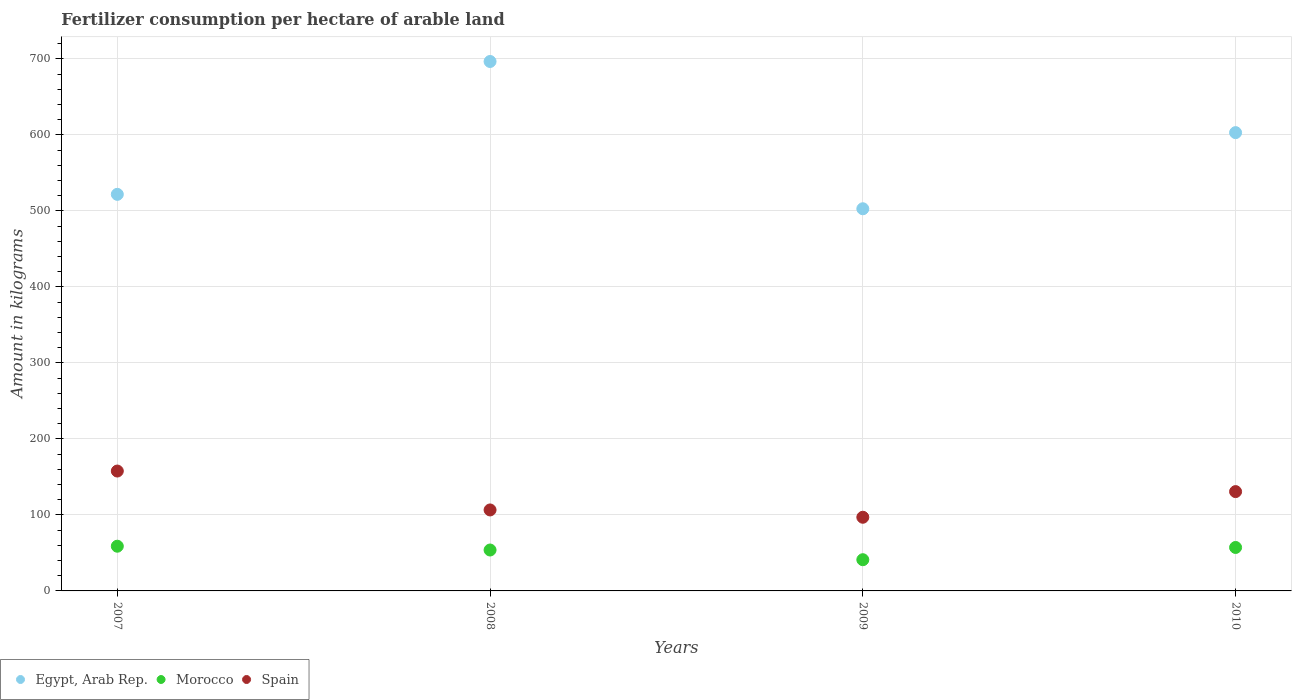Is the number of dotlines equal to the number of legend labels?
Offer a terse response. Yes. What is the amount of fertilizer consumption in Spain in 2008?
Give a very brief answer. 106.54. Across all years, what is the maximum amount of fertilizer consumption in Morocco?
Offer a very short reply. 58.83. Across all years, what is the minimum amount of fertilizer consumption in Morocco?
Your response must be concise. 41.07. What is the total amount of fertilizer consumption in Egypt, Arab Rep. in the graph?
Give a very brief answer. 2324.19. What is the difference between the amount of fertilizer consumption in Spain in 2007 and that in 2008?
Offer a terse response. 51.18. What is the difference between the amount of fertilizer consumption in Egypt, Arab Rep. in 2009 and the amount of fertilizer consumption in Morocco in 2008?
Offer a terse response. 449. What is the average amount of fertilizer consumption in Morocco per year?
Give a very brief answer. 52.72. In the year 2008, what is the difference between the amount of fertilizer consumption in Morocco and amount of fertilizer consumption in Egypt, Arab Rep.?
Your answer should be very brief. -642.77. What is the ratio of the amount of fertilizer consumption in Egypt, Arab Rep. in 2007 to that in 2008?
Offer a terse response. 0.75. Is the amount of fertilizer consumption in Morocco in 2008 less than that in 2010?
Offer a very short reply. Yes. What is the difference between the highest and the second highest amount of fertilizer consumption in Egypt, Arab Rep.?
Provide a succinct answer. 93.61. What is the difference between the highest and the lowest amount of fertilizer consumption in Spain?
Ensure brevity in your answer.  60.8. In how many years, is the amount of fertilizer consumption in Spain greater than the average amount of fertilizer consumption in Spain taken over all years?
Ensure brevity in your answer.  2. Is the amount of fertilizer consumption in Egypt, Arab Rep. strictly greater than the amount of fertilizer consumption in Morocco over the years?
Your response must be concise. Yes. Are the values on the major ticks of Y-axis written in scientific E-notation?
Your answer should be compact. No. Does the graph contain any zero values?
Make the answer very short. No. How many legend labels are there?
Give a very brief answer. 3. How are the legend labels stacked?
Provide a short and direct response. Horizontal. What is the title of the graph?
Your response must be concise. Fertilizer consumption per hectare of arable land. Does "French Polynesia" appear as one of the legend labels in the graph?
Give a very brief answer. No. What is the label or title of the X-axis?
Keep it short and to the point. Years. What is the label or title of the Y-axis?
Your answer should be compact. Amount in kilograms. What is the Amount in kilograms of Egypt, Arab Rep. in 2007?
Make the answer very short. 521.79. What is the Amount in kilograms of Morocco in 2007?
Keep it short and to the point. 58.83. What is the Amount in kilograms in Spain in 2007?
Provide a succinct answer. 157.72. What is the Amount in kilograms in Egypt, Arab Rep. in 2008?
Ensure brevity in your answer.  696.59. What is the Amount in kilograms of Morocco in 2008?
Provide a succinct answer. 53.83. What is the Amount in kilograms in Spain in 2008?
Provide a short and direct response. 106.54. What is the Amount in kilograms of Egypt, Arab Rep. in 2009?
Provide a succinct answer. 502.83. What is the Amount in kilograms of Morocco in 2009?
Your answer should be compact. 41.07. What is the Amount in kilograms in Spain in 2009?
Offer a very short reply. 96.93. What is the Amount in kilograms in Egypt, Arab Rep. in 2010?
Provide a succinct answer. 602.99. What is the Amount in kilograms in Morocco in 2010?
Your response must be concise. 57.17. What is the Amount in kilograms of Spain in 2010?
Offer a very short reply. 130.68. Across all years, what is the maximum Amount in kilograms in Egypt, Arab Rep.?
Your answer should be compact. 696.59. Across all years, what is the maximum Amount in kilograms of Morocco?
Your answer should be compact. 58.83. Across all years, what is the maximum Amount in kilograms in Spain?
Provide a succinct answer. 157.72. Across all years, what is the minimum Amount in kilograms of Egypt, Arab Rep.?
Give a very brief answer. 502.83. Across all years, what is the minimum Amount in kilograms in Morocco?
Ensure brevity in your answer.  41.07. Across all years, what is the minimum Amount in kilograms of Spain?
Ensure brevity in your answer.  96.93. What is the total Amount in kilograms of Egypt, Arab Rep. in the graph?
Offer a terse response. 2324.19. What is the total Amount in kilograms in Morocco in the graph?
Give a very brief answer. 210.89. What is the total Amount in kilograms in Spain in the graph?
Your response must be concise. 491.87. What is the difference between the Amount in kilograms in Egypt, Arab Rep. in 2007 and that in 2008?
Your answer should be very brief. -174.81. What is the difference between the Amount in kilograms of Morocco in 2007 and that in 2008?
Provide a succinct answer. 5. What is the difference between the Amount in kilograms in Spain in 2007 and that in 2008?
Offer a very short reply. 51.18. What is the difference between the Amount in kilograms in Egypt, Arab Rep. in 2007 and that in 2009?
Make the answer very short. 18.96. What is the difference between the Amount in kilograms in Morocco in 2007 and that in 2009?
Ensure brevity in your answer.  17.76. What is the difference between the Amount in kilograms of Spain in 2007 and that in 2009?
Your response must be concise. 60.8. What is the difference between the Amount in kilograms in Egypt, Arab Rep. in 2007 and that in 2010?
Your answer should be compact. -81.2. What is the difference between the Amount in kilograms of Morocco in 2007 and that in 2010?
Make the answer very short. 1.66. What is the difference between the Amount in kilograms in Spain in 2007 and that in 2010?
Give a very brief answer. 27.05. What is the difference between the Amount in kilograms of Egypt, Arab Rep. in 2008 and that in 2009?
Your answer should be compact. 193.77. What is the difference between the Amount in kilograms in Morocco in 2008 and that in 2009?
Offer a terse response. 12.76. What is the difference between the Amount in kilograms in Spain in 2008 and that in 2009?
Ensure brevity in your answer.  9.62. What is the difference between the Amount in kilograms of Egypt, Arab Rep. in 2008 and that in 2010?
Give a very brief answer. 93.61. What is the difference between the Amount in kilograms in Morocco in 2008 and that in 2010?
Give a very brief answer. -3.34. What is the difference between the Amount in kilograms in Spain in 2008 and that in 2010?
Your answer should be compact. -24.13. What is the difference between the Amount in kilograms in Egypt, Arab Rep. in 2009 and that in 2010?
Provide a succinct answer. -100.16. What is the difference between the Amount in kilograms of Morocco in 2009 and that in 2010?
Your answer should be compact. -16.11. What is the difference between the Amount in kilograms in Spain in 2009 and that in 2010?
Make the answer very short. -33.75. What is the difference between the Amount in kilograms in Egypt, Arab Rep. in 2007 and the Amount in kilograms in Morocco in 2008?
Ensure brevity in your answer.  467.96. What is the difference between the Amount in kilograms in Egypt, Arab Rep. in 2007 and the Amount in kilograms in Spain in 2008?
Offer a terse response. 415.24. What is the difference between the Amount in kilograms in Morocco in 2007 and the Amount in kilograms in Spain in 2008?
Offer a very short reply. -47.72. What is the difference between the Amount in kilograms of Egypt, Arab Rep. in 2007 and the Amount in kilograms of Morocco in 2009?
Keep it short and to the point. 480.72. What is the difference between the Amount in kilograms in Egypt, Arab Rep. in 2007 and the Amount in kilograms in Spain in 2009?
Give a very brief answer. 424.86. What is the difference between the Amount in kilograms in Morocco in 2007 and the Amount in kilograms in Spain in 2009?
Provide a short and direct response. -38.1. What is the difference between the Amount in kilograms of Egypt, Arab Rep. in 2007 and the Amount in kilograms of Morocco in 2010?
Provide a short and direct response. 464.62. What is the difference between the Amount in kilograms of Egypt, Arab Rep. in 2007 and the Amount in kilograms of Spain in 2010?
Offer a very short reply. 391.11. What is the difference between the Amount in kilograms of Morocco in 2007 and the Amount in kilograms of Spain in 2010?
Provide a succinct answer. -71.85. What is the difference between the Amount in kilograms in Egypt, Arab Rep. in 2008 and the Amount in kilograms in Morocco in 2009?
Provide a short and direct response. 655.53. What is the difference between the Amount in kilograms in Egypt, Arab Rep. in 2008 and the Amount in kilograms in Spain in 2009?
Offer a terse response. 599.67. What is the difference between the Amount in kilograms in Morocco in 2008 and the Amount in kilograms in Spain in 2009?
Provide a succinct answer. -43.1. What is the difference between the Amount in kilograms in Egypt, Arab Rep. in 2008 and the Amount in kilograms in Morocco in 2010?
Offer a very short reply. 639.42. What is the difference between the Amount in kilograms in Egypt, Arab Rep. in 2008 and the Amount in kilograms in Spain in 2010?
Provide a short and direct response. 565.92. What is the difference between the Amount in kilograms of Morocco in 2008 and the Amount in kilograms of Spain in 2010?
Provide a succinct answer. -76.85. What is the difference between the Amount in kilograms in Egypt, Arab Rep. in 2009 and the Amount in kilograms in Morocco in 2010?
Provide a succinct answer. 445.65. What is the difference between the Amount in kilograms of Egypt, Arab Rep. in 2009 and the Amount in kilograms of Spain in 2010?
Make the answer very short. 372.15. What is the difference between the Amount in kilograms of Morocco in 2009 and the Amount in kilograms of Spain in 2010?
Offer a terse response. -89.61. What is the average Amount in kilograms in Egypt, Arab Rep. per year?
Make the answer very short. 581.05. What is the average Amount in kilograms of Morocco per year?
Provide a short and direct response. 52.72. What is the average Amount in kilograms in Spain per year?
Your response must be concise. 122.97. In the year 2007, what is the difference between the Amount in kilograms of Egypt, Arab Rep. and Amount in kilograms of Morocco?
Offer a very short reply. 462.96. In the year 2007, what is the difference between the Amount in kilograms in Egypt, Arab Rep. and Amount in kilograms in Spain?
Give a very brief answer. 364.07. In the year 2007, what is the difference between the Amount in kilograms of Morocco and Amount in kilograms of Spain?
Ensure brevity in your answer.  -98.89. In the year 2008, what is the difference between the Amount in kilograms of Egypt, Arab Rep. and Amount in kilograms of Morocco?
Give a very brief answer. 642.77. In the year 2008, what is the difference between the Amount in kilograms of Egypt, Arab Rep. and Amount in kilograms of Spain?
Your response must be concise. 590.05. In the year 2008, what is the difference between the Amount in kilograms of Morocco and Amount in kilograms of Spain?
Offer a very short reply. -52.72. In the year 2009, what is the difference between the Amount in kilograms of Egypt, Arab Rep. and Amount in kilograms of Morocco?
Offer a very short reply. 461.76. In the year 2009, what is the difference between the Amount in kilograms in Egypt, Arab Rep. and Amount in kilograms in Spain?
Ensure brevity in your answer.  405.9. In the year 2009, what is the difference between the Amount in kilograms in Morocco and Amount in kilograms in Spain?
Provide a short and direct response. -55.86. In the year 2010, what is the difference between the Amount in kilograms of Egypt, Arab Rep. and Amount in kilograms of Morocco?
Ensure brevity in your answer.  545.82. In the year 2010, what is the difference between the Amount in kilograms of Egypt, Arab Rep. and Amount in kilograms of Spain?
Provide a succinct answer. 472.31. In the year 2010, what is the difference between the Amount in kilograms of Morocco and Amount in kilograms of Spain?
Keep it short and to the point. -73.5. What is the ratio of the Amount in kilograms in Egypt, Arab Rep. in 2007 to that in 2008?
Provide a short and direct response. 0.75. What is the ratio of the Amount in kilograms in Morocco in 2007 to that in 2008?
Offer a terse response. 1.09. What is the ratio of the Amount in kilograms of Spain in 2007 to that in 2008?
Offer a terse response. 1.48. What is the ratio of the Amount in kilograms in Egypt, Arab Rep. in 2007 to that in 2009?
Keep it short and to the point. 1.04. What is the ratio of the Amount in kilograms in Morocco in 2007 to that in 2009?
Your response must be concise. 1.43. What is the ratio of the Amount in kilograms of Spain in 2007 to that in 2009?
Make the answer very short. 1.63. What is the ratio of the Amount in kilograms of Egypt, Arab Rep. in 2007 to that in 2010?
Give a very brief answer. 0.87. What is the ratio of the Amount in kilograms of Spain in 2007 to that in 2010?
Offer a terse response. 1.21. What is the ratio of the Amount in kilograms in Egypt, Arab Rep. in 2008 to that in 2009?
Give a very brief answer. 1.39. What is the ratio of the Amount in kilograms in Morocco in 2008 to that in 2009?
Provide a succinct answer. 1.31. What is the ratio of the Amount in kilograms in Spain in 2008 to that in 2009?
Offer a terse response. 1.1. What is the ratio of the Amount in kilograms of Egypt, Arab Rep. in 2008 to that in 2010?
Your answer should be very brief. 1.16. What is the ratio of the Amount in kilograms in Morocco in 2008 to that in 2010?
Your answer should be very brief. 0.94. What is the ratio of the Amount in kilograms in Spain in 2008 to that in 2010?
Your answer should be very brief. 0.82. What is the ratio of the Amount in kilograms of Egypt, Arab Rep. in 2009 to that in 2010?
Keep it short and to the point. 0.83. What is the ratio of the Amount in kilograms in Morocco in 2009 to that in 2010?
Your response must be concise. 0.72. What is the ratio of the Amount in kilograms in Spain in 2009 to that in 2010?
Give a very brief answer. 0.74. What is the difference between the highest and the second highest Amount in kilograms of Egypt, Arab Rep.?
Provide a short and direct response. 93.61. What is the difference between the highest and the second highest Amount in kilograms in Morocco?
Ensure brevity in your answer.  1.66. What is the difference between the highest and the second highest Amount in kilograms of Spain?
Ensure brevity in your answer.  27.05. What is the difference between the highest and the lowest Amount in kilograms of Egypt, Arab Rep.?
Keep it short and to the point. 193.77. What is the difference between the highest and the lowest Amount in kilograms in Morocco?
Your answer should be compact. 17.76. What is the difference between the highest and the lowest Amount in kilograms in Spain?
Ensure brevity in your answer.  60.8. 